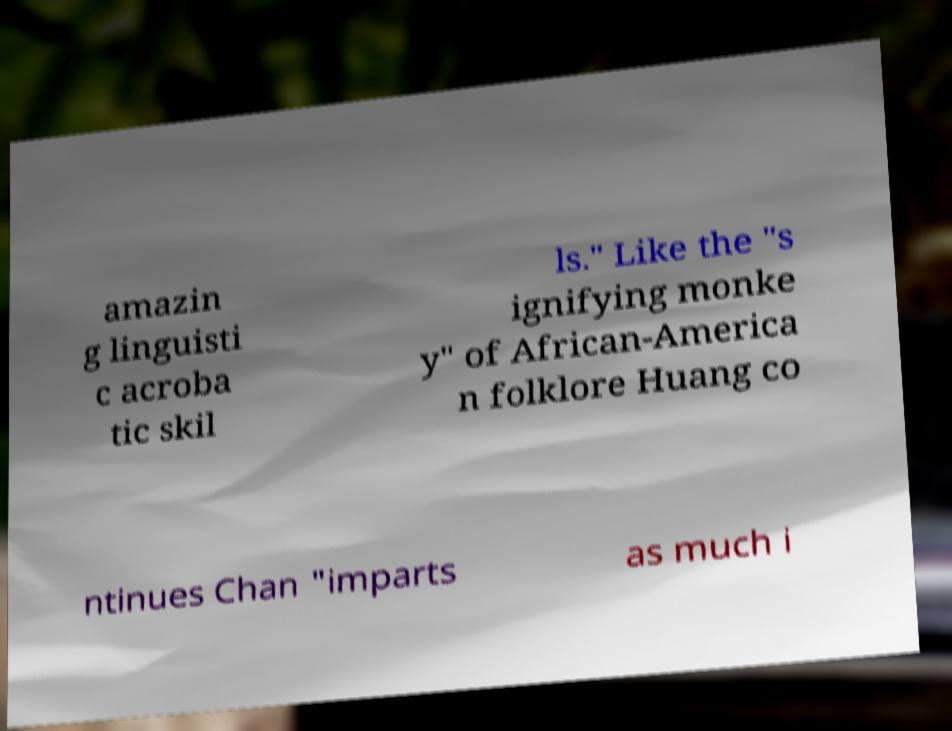Can you read and provide the text displayed in the image?This photo seems to have some interesting text. Can you extract and type it out for me? amazin g linguisti c acroba tic skil ls." Like the "s ignifying monke y" of African-America n folklore Huang co ntinues Chan "imparts as much i 